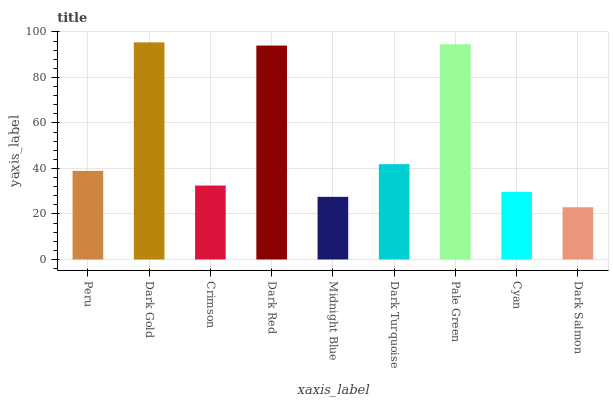Is Dark Salmon the minimum?
Answer yes or no. Yes. Is Dark Gold the maximum?
Answer yes or no. Yes. Is Crimson the minimum?
Answer yes or no. No. Is Crimson the maximum?
Answer yes or no. No. Is Dark Gold greater than Crimson?
Answer yes or no. Yes. Is Crimson less than Dark Gold?
Answer yes or no. Yes. Is Crimson greater than Dark Gold?
Answer yes or no. No. Is Dark Gold less than Crimson?
Answer yes or no. No. Is Peru the high median?
Answer yes or no. Yes. Is Peru the low median?
Answer yes or no. Yes. Is Pale Green the high median?
Answer yes or no. No. Is Dark Gold the low median?
Answer yes or no. No. 